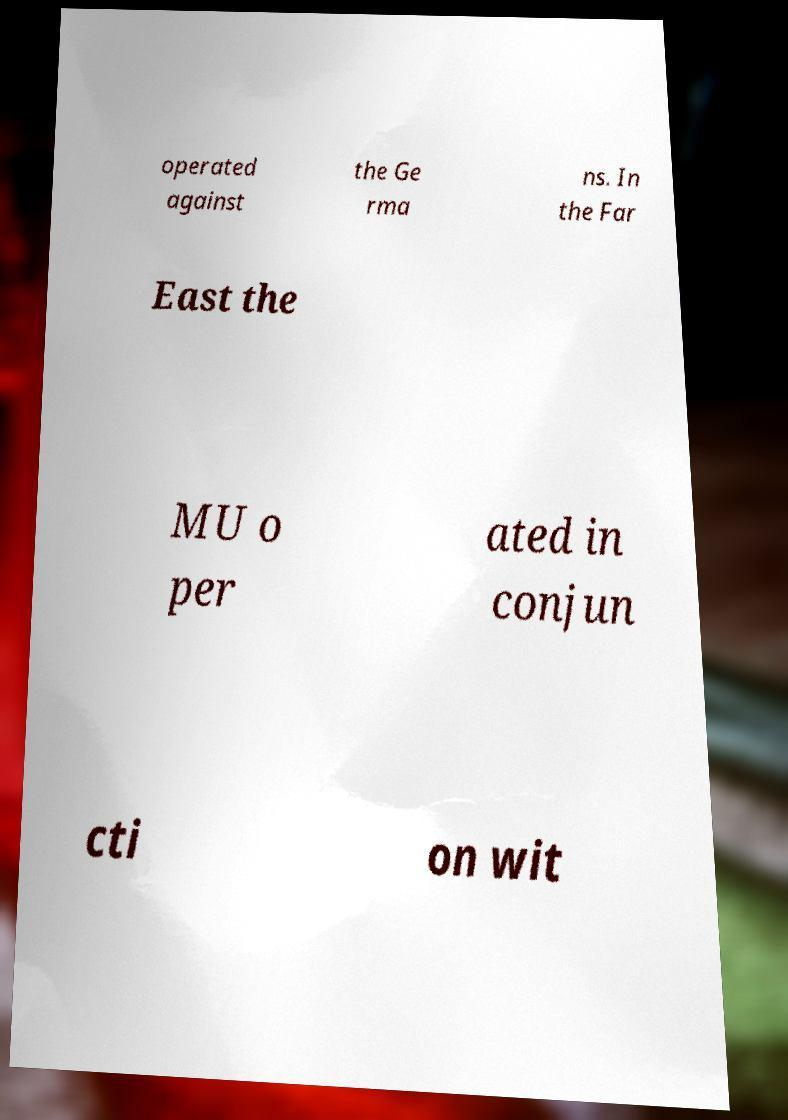There's text embedded in this image that I need extracted. Can you transcribe it verbatim? operated against the Ge rma ns. In the Far East the MU o per ated in conjun cti on wit 